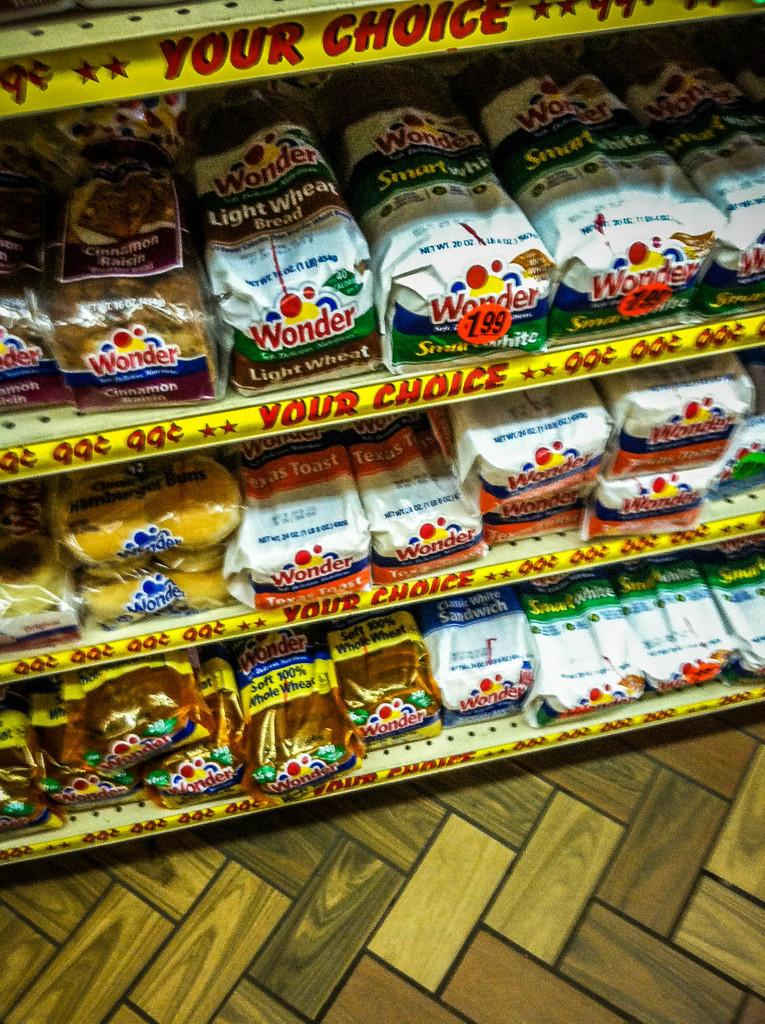Provide a one-sentence caption for the provided image. Bread aisle showing many breads and one for 1.99. 